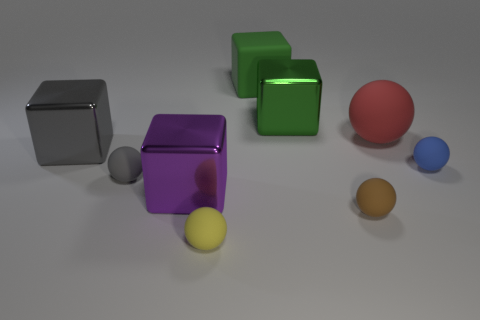What number of other objects are there of the same size as the brown object?
Keep it short and to the point. 3. The thing that is both right of the green shiny block and on the left side of the large red rubber object is made of what material?
Give a very brief answer. Rubber. What is the material of the yellow object that is the same shape as the gray matte object?
Your answer should be compact. Rubber. How many big blocks are to the left of the big metal cube that is right of the purple cube in front of the gray ball?
Offer a terse response. 3. Are there any other things that have the same color as the large ball?
Provide a succinct answer. No. What number of matte balls are to the right of the gray rubber ball and behind the tiny brown matte object?
Keep it short and to the point. 2. There is a ball that is behind the blue thing; does it have the same size as the object on the left side of the small gray object?
Give a very brief answer. Yes. What number of things are either big blocks behind the big rubber sphere or large cyan rubber blocks?
Provide a succinct answer. 2. There is a tiny object on the right side of the big red rubber sphere; what is its material?
Provide a succinct answer. Rubber. What material is the big red object?
Ensure brevity in your answer.  Rubber. 